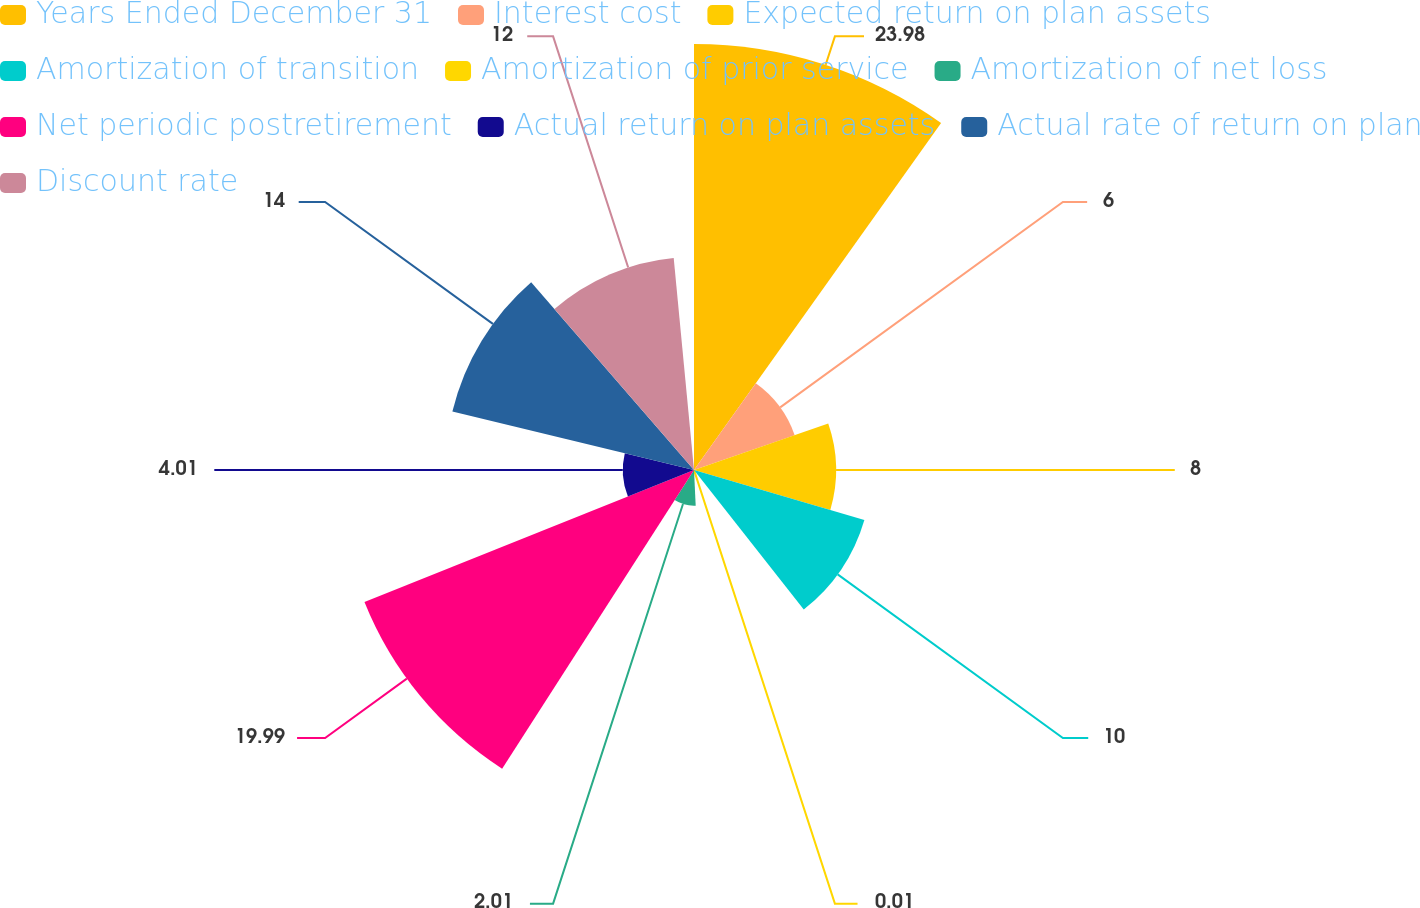Convert chart to OTSL. <chart><loc_0><loc_0><loc_500><loc_500><pie_chart><fcel>Years Ended December 31<fcel>Interest cost<fcel>Expected return on plan assets<fcel>Amortization of transition<fcel>Amortization of prior service<fcel>Amortization of net loss<fcel>Net periodic postretirement<fcel>Actual return on plan assets<fcel>Actual rate of return on plan<fcel>Discount rate<nl><fcel>23.99%<fcel>6.0%<fcel>8.0%<fcel>10.0%<fcel>0.01%<fcel>2.01%<fcel>19.99%<fcel>4.01%<fcel>14.0%<fcel>12.0%<nl></chart> 